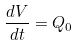Convert formula to latex. <formula><loc_0><loc_0><loc_500><loc_500>\frac { d V } { d t } = Q _ { 0 }</formula> 